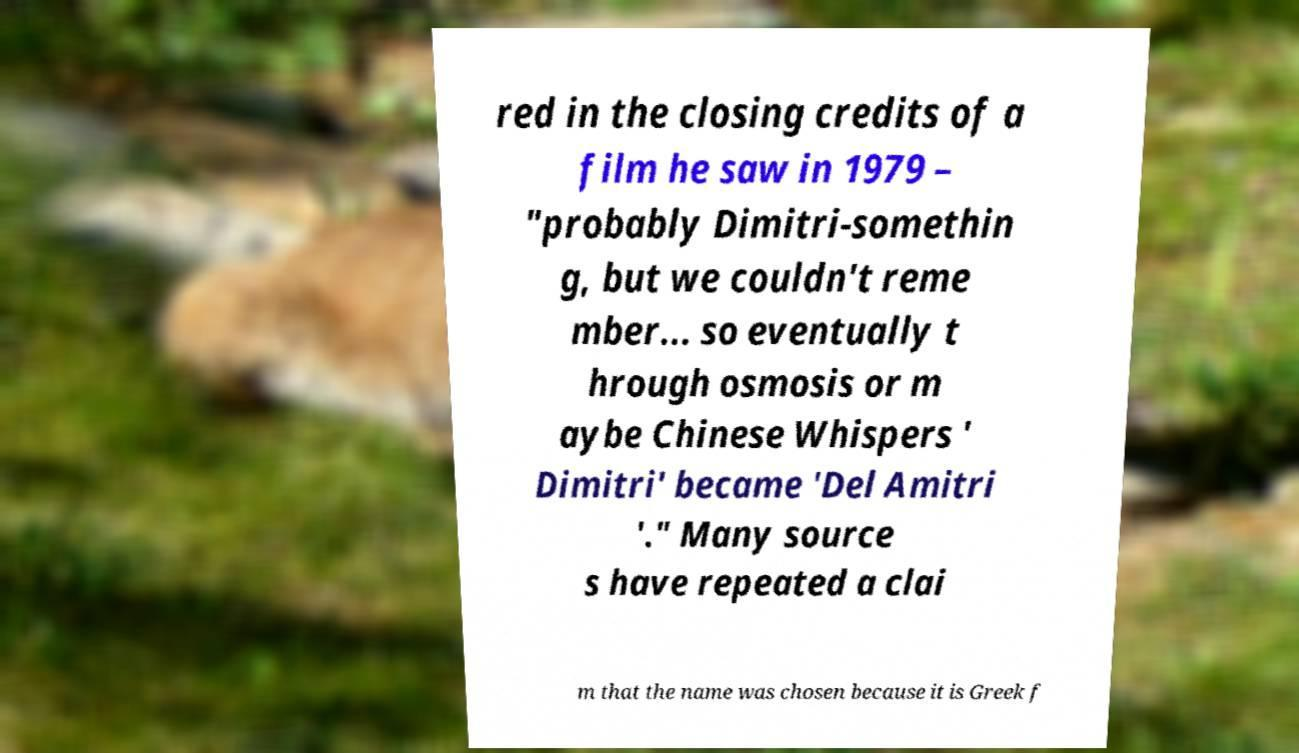There's text embedded in this image that I need extracted. Can you transcribe it verbatim? red in the closing credits of a film he saw in 1979 – "probably Dimitri-somethin g, but we couldn't reme mber... so eventually t hrough osmosis or m aybe Chinese Whispers ' Dimitri' became 'Del Amitri '." Many source s have repeated a clai m that the name was chosen because it is Greek f 